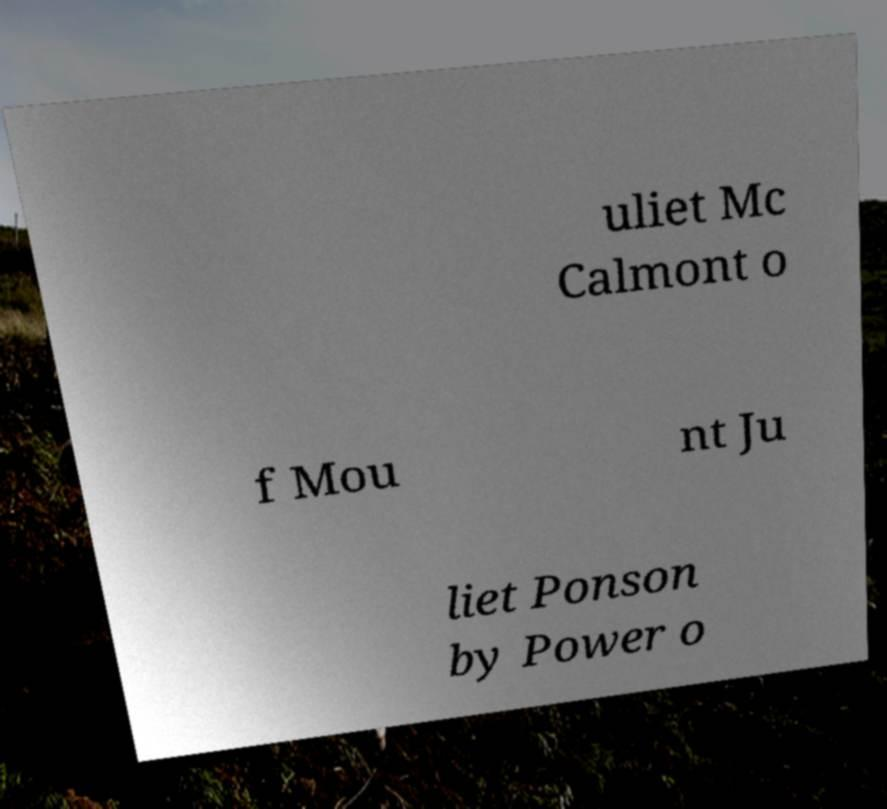What messages or text are displayed in this image? I need them in a readable, typed format. uliet Mc Calmont o f Mou nt Ju liet Ponson by Power o 